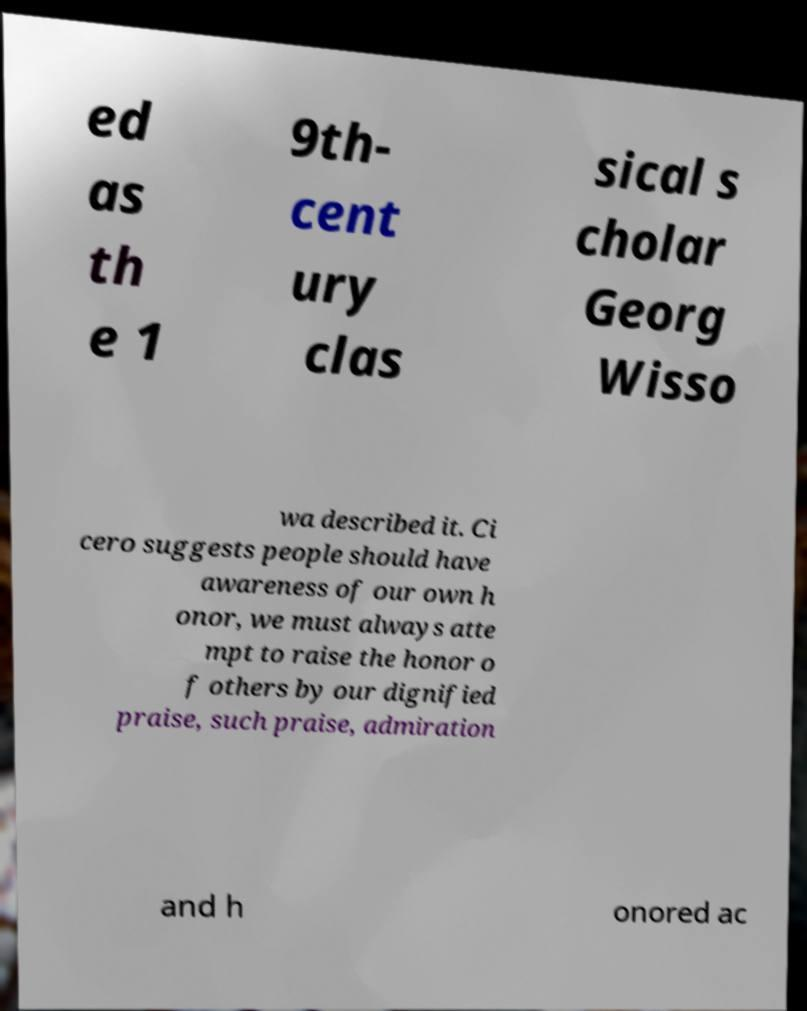Could you extract and type out the text from this image? ed as th e 1 9th- cent ury clas sical s cholar Georg Wisso wa described it. Ci cero suggests people should have awareness of our own h onor, we must always atte mpt to raise the honor o f others by our dignified praise, such praise, admiration and h onored ac 